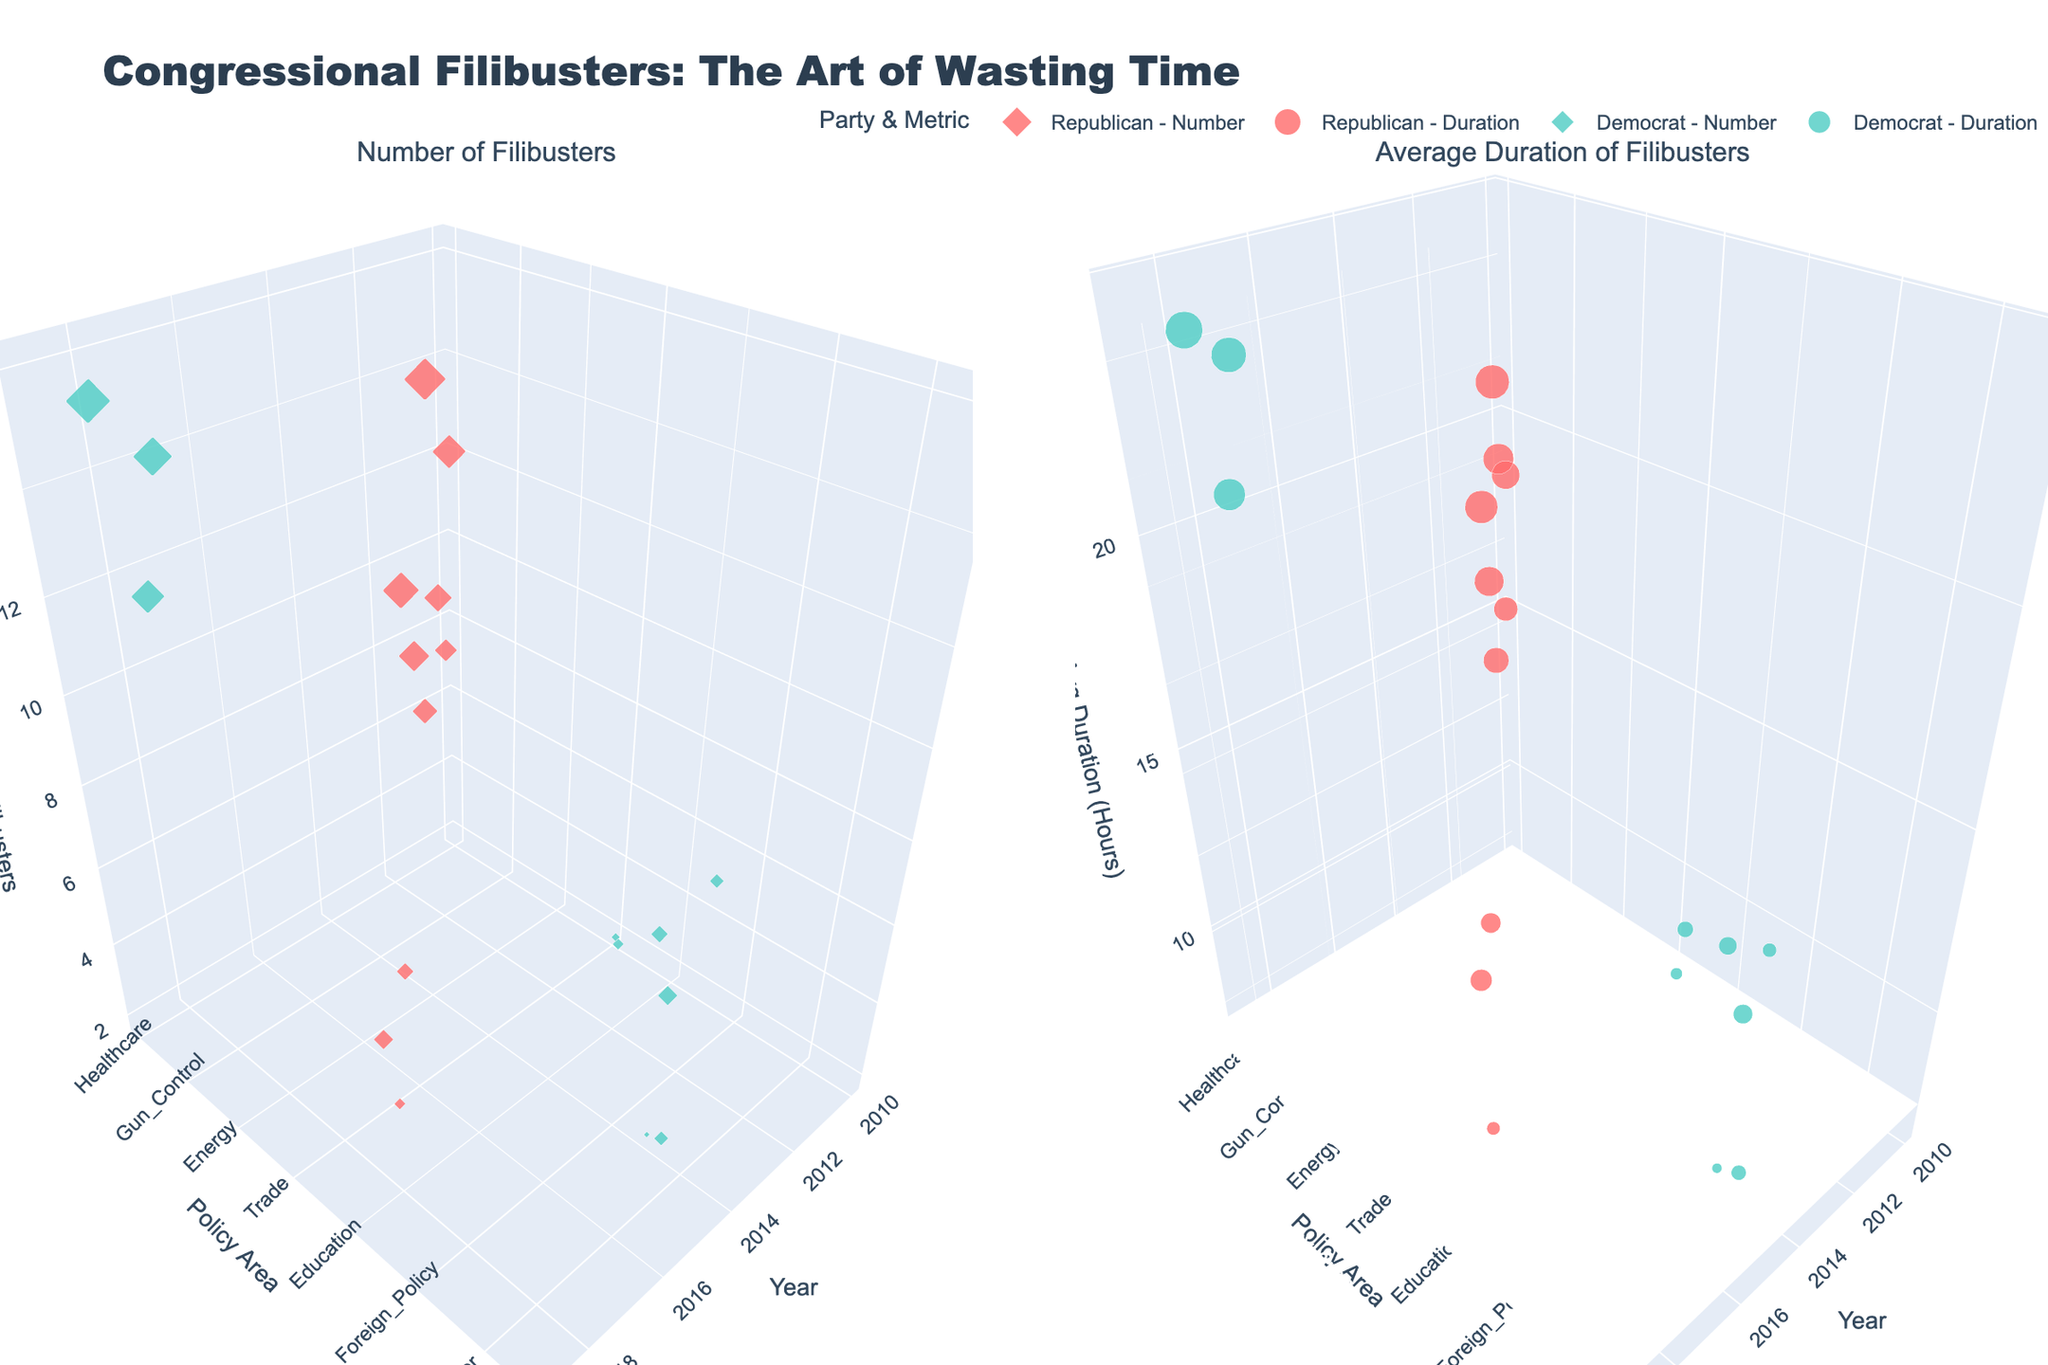what is the title of the figure? The title is displayed at the top of the figure and reads: "Congressional Filibusters: The Art of Wasting Time."
Answer: Congressional Filibusters: The Art of Wasting Time What are the axis titles for the subplot on the left? The subplot on the left represents the number of filibusters and the axes are titled "Year" for the x-axis, "Policy Area" for the y-axis, and "Number of Filibusters" for the z-axis.
Answer: Year, Policy Area, Number of Filibusters Which party had the highest number of filibusters in a single year, and what was the policy area? By observing the size and position of the markers on the left subplot, the Republican party in 2013 had the highest number of filibusters with respect to the Budget policy area.
Answer: Republican, Budget In 2019, which policy area had the highest average duration of filibusters, and which party led it? Referring to the subplot on the right, the largest marker in 2019 is for Gun Control policy area, led by the Democratic party.
Answer: Gun Control, Democrat What is the average duration of filibusters for Healthcare policy in 2017 compared to 2010? By comparing the marker sizes on the right subplot: for 2010, the average duration is 18.5 hours (Republican), and for 2017, it is 23.1 hours (Democrat). The average duration is higher in 2017.
Answer: Higher in 2017 Which policy area did Republicans focus on the most in 2016, and what was the average duration? The largest marker in 2016 on the left subplot is for Trade, indicating Republicans were most focused on this area. The corresponding marker on the right subplot reveals an average duration of 21.6 hours.
Answer: Trade, 21.6 hours How did the number of filibusters for Immigration policy compare between Republicans and Democrats across all years? Observing the left subplot, Immigration filibusters for Republicans are 6 (2017) + 3 (2011) = 9 filibusters; for Democrats, it is 3 (2011). Republicans had more filibusters for this policy.
Answer: Republicans had more Which party had the longest average filibuster duration for any policy, and what is the duration? The largest marker on the right subplot represents the 2019 Gun Control policy area, led by the Democratic party, with an average duration of 24.5 hours.
Answer: Democrat, 24.5 hours Between 2014 and 2018, which policy area saw a significant shift in the number of filibusters by Republicans? Reviewing changes over time on the left subplot, the Education policy area shifts from 0 filibusters before 2018 to 4 filibusters by Republicans in 2018.
Answer: Education policy 